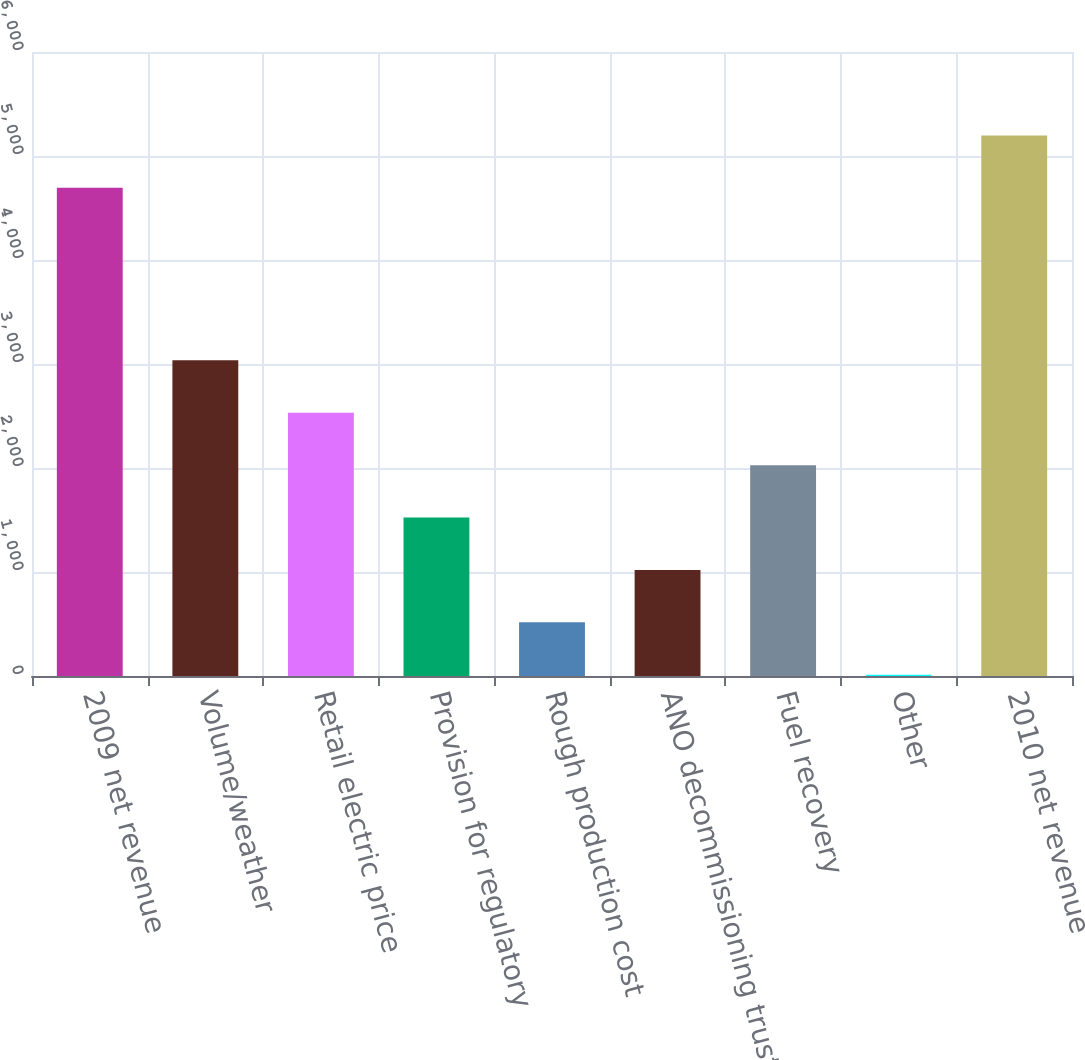<chart> <loc_0><loc_0><loc_500><loc_500><bar_chart><fcel>2009 net revenue<fcel>Volume/weather<fcel>Retail electric price<fcel>Provision for regulatory<fcel>Rough production cost<fcel>ANO decommissioning trust<fcel>Fuel recovery<fcel>Other<fcel>2010 net revenue<nl><fcel>4694<fcel>3035.4<fcel>2531.5<fcel>1523.7<fcel>515.9<fcel>1019.8<fcel>2027.6<fcel>12<fcel>5197.9<nl></chart> 